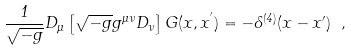<formula> <loc_0><loc_0><loc_500><loc_500>\frac { 1 } { \sqrt { - g } } D _ { \mu } \left [ \sqrt { - g } g ^ { \mu \nu } D _ { \nu } \right ] G ( x , x ^ { ^ { \prime } } ) = - \delta ^ { ( 4 ) } ( x - x ^ { \prime } ) \ ,</formula> 